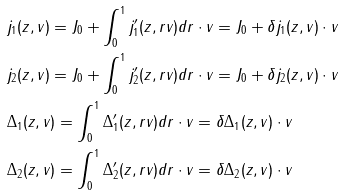Convert formula to latex. <formula><loc_0><loc_0><loc_500><loc_500>& j _ { 1 } ( z , v ) = J _ { 0 } + \int _ { 0 } ^ { 1 } j _ { 1 } ^ { \prime } ( z , r v ) d r \cdot v = J _ { 0 } + \delta j _ { 1 } ( z , v ) \cdot v \\ & j _ { 2 } ( z , v ) = J _ { 0 } + \int _ { 0 } ^ { 1 } j _ { 2 } ^ { \prime } ( z , r v ) d r \cdot v = J _ { 0 } + \delta j _ { 2 } ( z , v ) \cdot v \\ & \Delta _ { 1 } ( z , v ) = \int _ { 0 } ^ { 1 } \Delta _ { 1 } ^ { \prime } ( z , r v ) d r \cdot v = \delta \Delta _ { 1 } ( z , v ) \cdot v \\ & \Delta _ { 2 } ( z , v ) = \int _ { 0 } ^ { 1 } \Delta _ { 2 } ^ { \prime } ( z , r v ) d r \cdot v = \delta \Delta _ { 2 } ( z , v ) \cdot v</formula> 